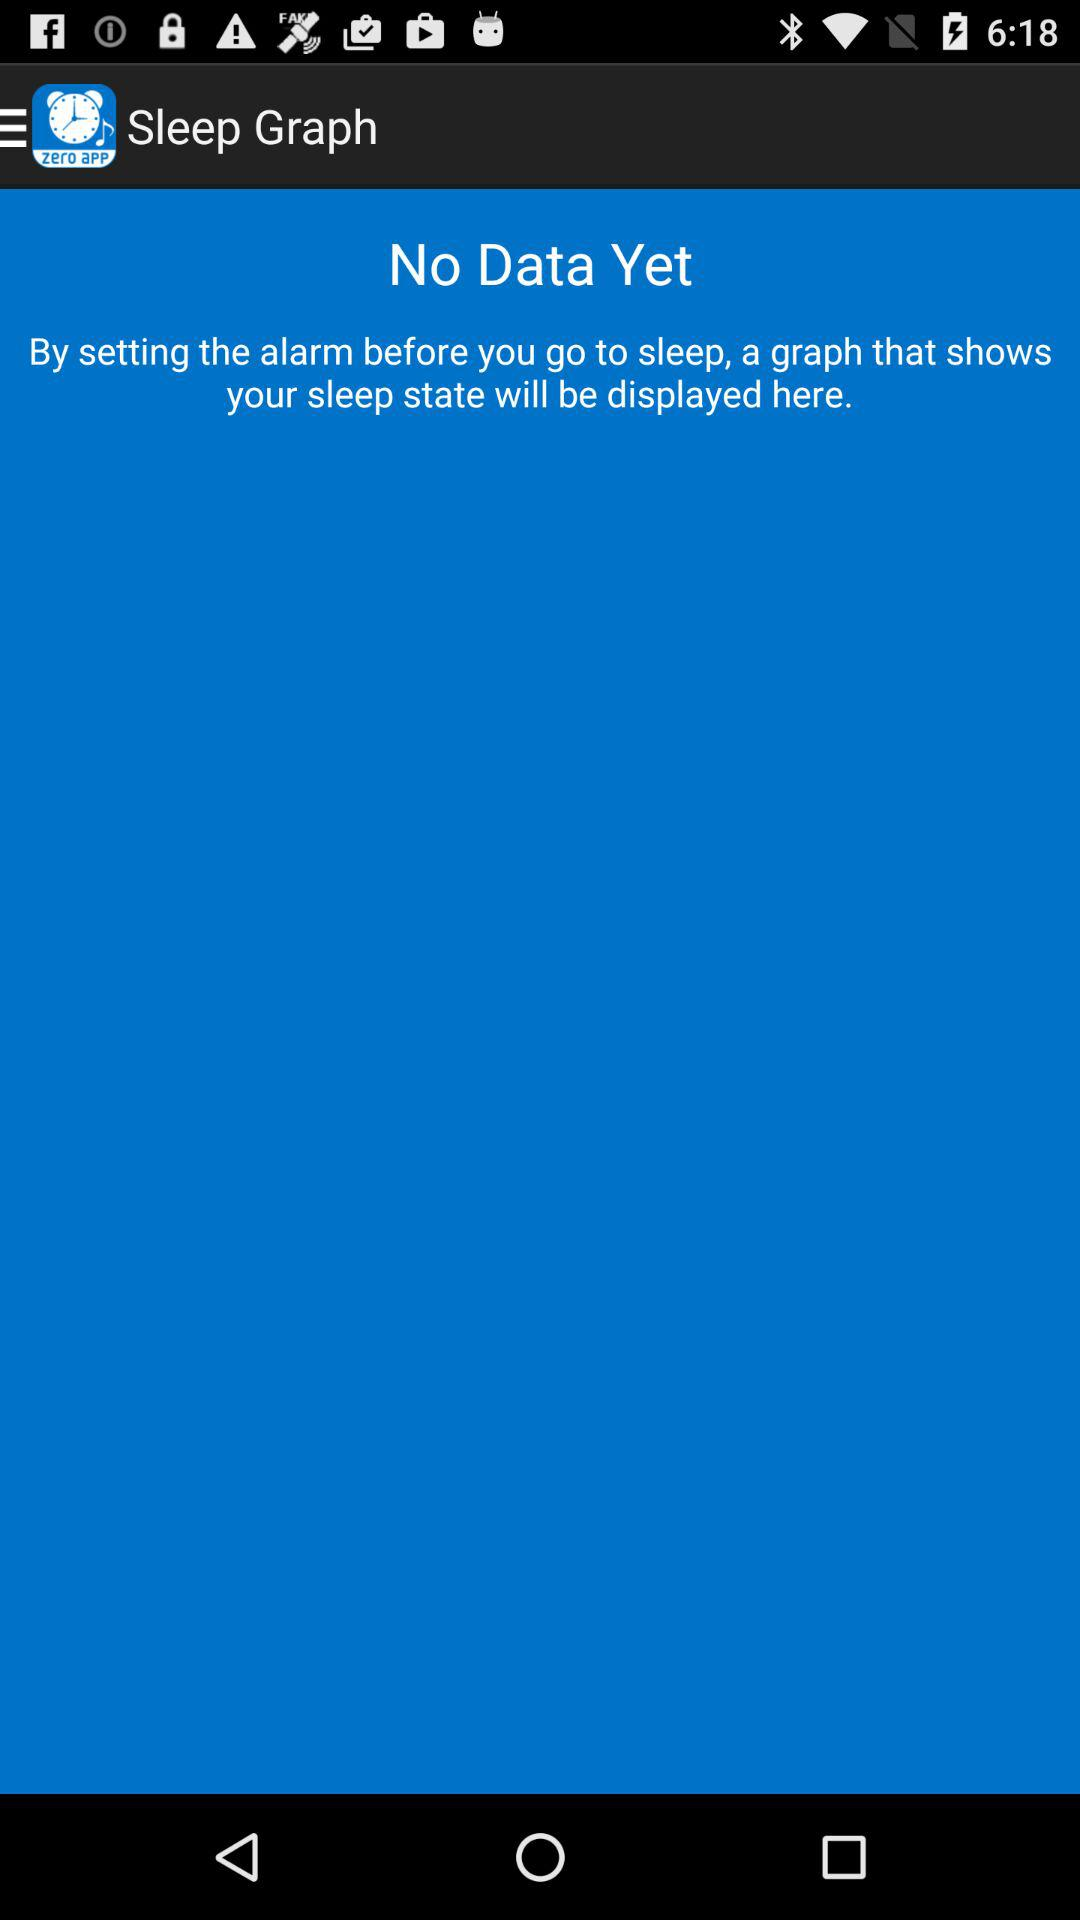What is the name of the application? The name of the application is "Sleep Graph". 